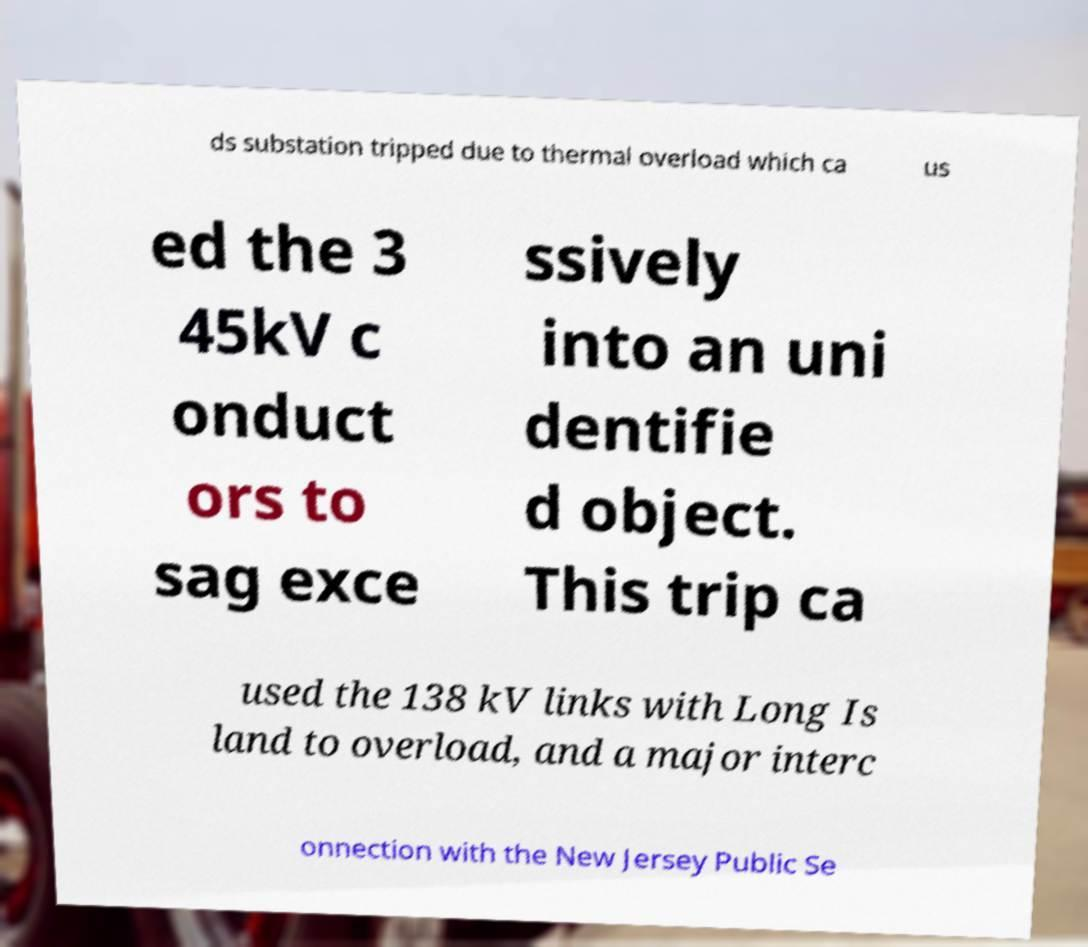Could you assist in decoding the text presented in this image and type it out clearly? ds substation tripped due to thermal overload which ca us ed the 3 45kV c onduct ors to sag exce ssively into an uni dentifie d object. This trip ca used the 138 kV links with Long Is land to overload, and a major interc onnection with the New Jersey Public Se 